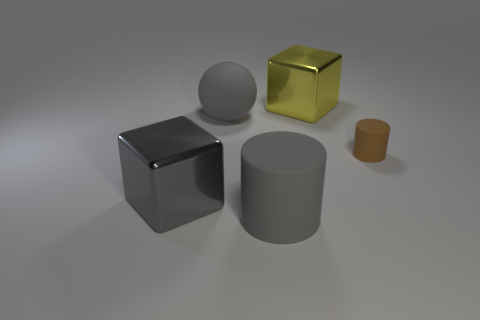What size is the brown object that is made of the same material as the gray sphere?
Provide a short and direct response. Small. There is a brown object; are there any tiny objects to the left of it?
Provide a succinct answer. No. Is the shape of the large yellow metallic thing the same as the gray metallic object?
Provide a succinct answer. Yes. What is the size of the matte cylinder that is right of the big block that is right of the rubber cylinder in front of the gray cube?
Keep it short and to the point. Small. What is the large gray block made of?
Offer a very short reply. Metal. There is a shiny cube that is the same color as the large sphere; what size is it?
Provide a short and direct response. Large. There is a yellow metal thing; is its shape the same as the gray object that is on the right side of the gray sphere?
Offer a very short reply. No. What material is the yellow object behind the matte cylinder that is to the left of the large shiny object that is on the right side of the big sphere?
Provide a short and direct response. Metal. How many cubes are there?
Make the answer very short. 2. What number of gray objects are large metallic objects or large rubber objects?
Give a very brief answer. 3. 